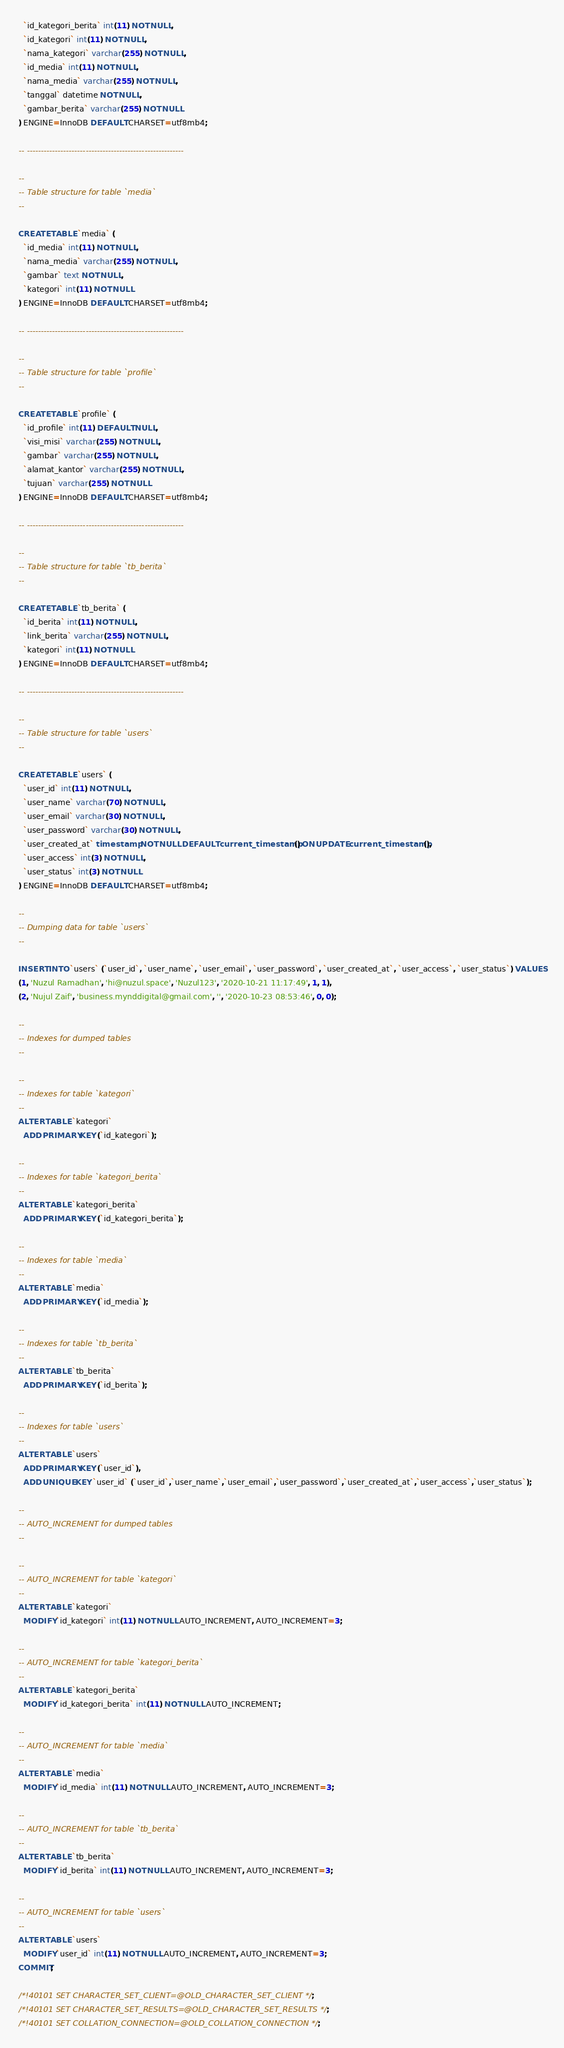Convert code to text. <code><loc_0><loc_0><loc_500><loc_500><_SQL_>  `id_kategori_berita` int(11) NOT NULL,
  `id_kategori` int(11) NOT NULL,
  `nama_kategori` varchar(255) NOT NULL,
  `id_media` int(11) NOT NULL,
  `nama_media` varchar(255) NOT NULL,
  `tanggal` datetime NOT NULL,
  `gambar_berita` varchar(255) NOT NULL
) ENGINE=InnoDB DEFAULT CHARSET=utf8mb4;

-- --------------------------------------------------------

--
-- Table structure for table `media`
--

CREATE TABLE `media` (
  `id_media` int(11) NOT NULL,
  `nama_media` varchar(255) NOT NULL,
  `gambar` text NOT NULL,
  `kategori` int(11) NOT NULL
) ENGINE=InnoDB DEFAULT CHARSET=utf8mb4;

-- --------------------------------------------------------

--
-- Table structure for table `profile`
--

CREATE TABLE `profile` (
  `id_profile` int(11) DEFAULT NULL,
  `visi_misi` varchar(255) NOT NULL,
  `gambar` varchar(255) NOT NULL,
  `alamat_kantor` varchar(255) NOT NULL,
  `tujuan` varchar(255) NOT NULL
) ENGINE=InnoDB DEFAULT CHARSET=utf8mb4;

-- --------------------------------------------------------

--
-- Table structure for table `tb_berita`
--

CREATE TABLE `tb_berita` (
  `id_berita` int(11) NOT NULL,
  `link_berita` varchar(255) NOT NULL,
  `kategori` int(11) NOT NULL
) ENGINE=InnoDB DEFAULT CHARSET=utf8mb4;

-- --------------------------------------------------------

--
-- Table structure for table `users`
--

CREATE TABLE `users` (
  `user_id` int(11) NOT NULL,
  `user_name` varchar(70) NOT NULL,
  `user_email` varchar(30) NOT NULL,
  `user_password` varchar(30) NOT NULL,
  `user_created_at` timestamp NOT NULL DEFAULT current_timestamp() ON UPDATE current_timestamp(),
  `user_access` int(3) NOT NULL,
  `user_status` int(3) NOT NULL
) ENGINE=InnoDB DEFAULT CHARSET=utf8mb4;

--
-- Dumping data for table `users`
--

INSERT INTO `users` (`user_id`, `user_name`, `user_email`, `user_password`, `user_created_at`, `user_access`, `user_status`) VALUES
(1, 'Nuzul Ramadhan', 'hi@nuzul.space', 'Nuzul123', '2020-10-21 11:17:49', 1, 1),
(2, 'Nujul Zaif', 'business.mynddigital@gmail.com', '', '2020-10-23 08:53:46', 0, 0);

--
-- Indexes for dumped tables
--

--
-- Indexes for table `kategori`
--
ALTER TABLE `kategori`
  ADD PRIMARY KEY (`id_kategori`);

--
-- Indexes for table `kategori_berita`
--
ALTER TABLE `kategori_berita`
  ADD PRIMARY KEY (`id_kategori_berita`);

--
-- Indexes for table `media`
--
ALTER TABLE `media`
  ADD PRIMARY KEY (`id_media`);

--
-- Indexes for table `tb_berita`
--
ALTER TABLE `tb_berita`
  ADD PRIMARY KEY (`id_berita`);

--
-- Indexes for table `users`
--
ALTER TABLE `users`
  ADD PRIMARY KEY (`user_id`),
  ADD UNIQUE KEY `user_id` (`user_id`,`user_name`,`user_email`,`user_password`,`user_created_at`,`user_access`,`user_status`);

--
-- AUTO_INCREMENT for dumped tables
--

--
-- AUTO_INCREMENT for table `kategori`
--
ALTER TABLE `kategori`
  MODIFY `id_kategori` int(11) NOT NULL AUTO_INCREMENT, AUTO_INCREMENT=3;

--
-- AUTO_INCREMENT for table `kategori_berita`
--
ALTER TABLE `kategori_berita`
  MODIFY `id_kategori_berita` int(11) NOT NULL AUTO_INCREMENT;

--
-- AUTO_INCREMENT for table `media`
--
ALTER TABLE `media`
  MODIFY `id_media` int(11) NOT NULL AUTO_INCREMENT, AUTO_INCREMENT=3;

--
-- AUTO_INCREMENT for table `tb_berita`
--
ALTER TABLE `tb_berita`
  MODIFY `id_berita` int(11) NOT NULL AUTO_INCREMENT, AUTO_INCREMENT=3;

--
-- AUTO_INCREMENT for table `users`
--
ALTER TABLE `users`
  MODIFY `user_id` int(11) NOT NULL AUTO_INCREMENT, AUTO_INCREMENT=3;
COMMIT;

/*!40101 SET CHARACTER_SET_CLIENT=@OLD_CHARACTER_SET_CLIENT */;
/*!40101 SET CHARACTER_SET_RESULTS=@OLD_CHARACTER_SET_RESULTS */;
/*!40101 SET COLLATION_CONNECTION=@OLD_COLLATION_CONNECTION */;
</code> 